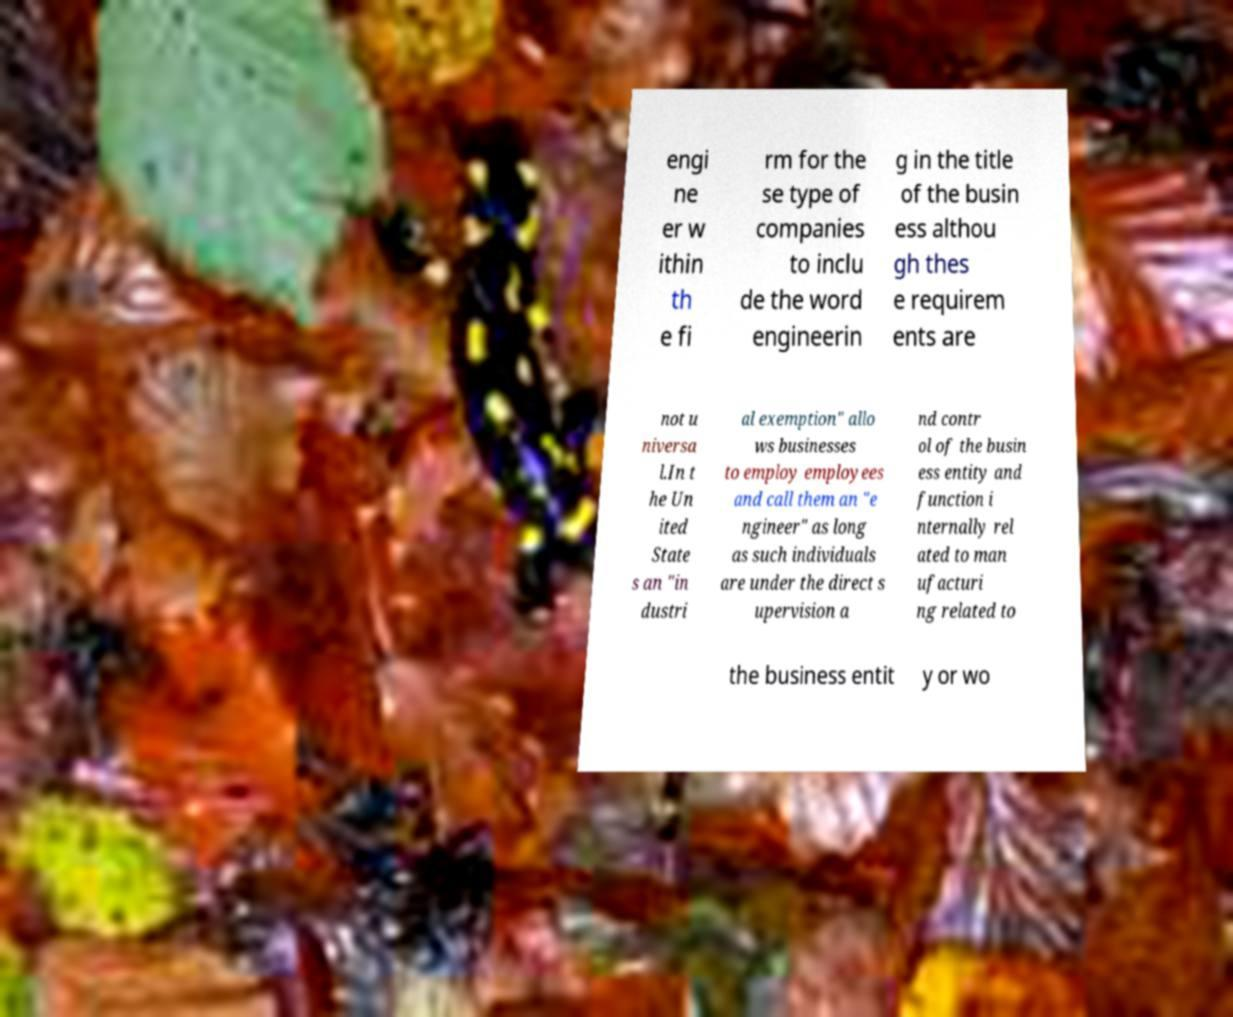Could you extract and type out the text from this image? engi ne er w ithin th e fi rm for the se type of companies to inclu de the word engineerin g in the title of the busin ess althou gh thes e requirem ents are not u niversa l.In t he Un ited State s an "in dustri al exemption" allo ws businesses to employ employees and call them an "e ngineer" as long as such individuals are under the direct s upervision a nd contr ol of the busin ess entity and function i nternally rel ated to man ufacturi ng related to the business entit y or wo 